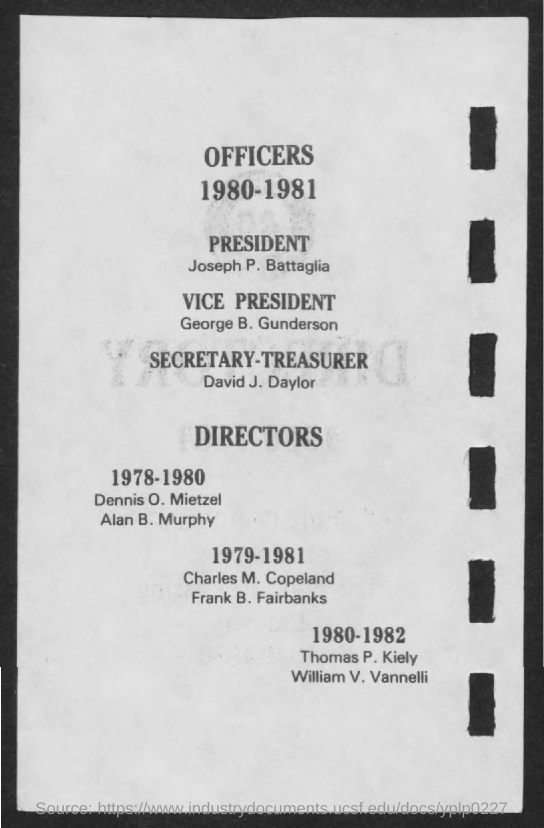Highlight a few significant elements in this photo. The Vice-President is George B. Gunderson. Thomas P. Kiely and William V. Vannelli were directors during the years 1980, 1981, and 1982. It is known that David J. Daylor is the Secretary-Treasurer. During the years 1979 to 1981, Charles M. Copeland and Frank B. Fairbanks served as directors. Joseph P. Battaglia is the President. 